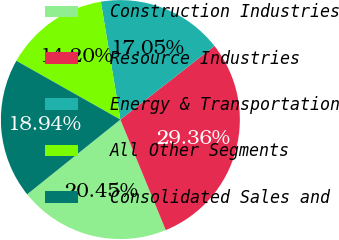<chart> <loc_0><loc_0><loc_500><loc_500><pie_chart><fcel>Construction Industries<fcel>Resource Industries<fcel>Energy & Transportation<fcel>All Other Segments<fcel>Consolidated Sales and<nl><fcel>20.45%<fcel>29.36%<fcel>17.05%<fcel>14.2%<fcel>18.94%<nl></chart> 